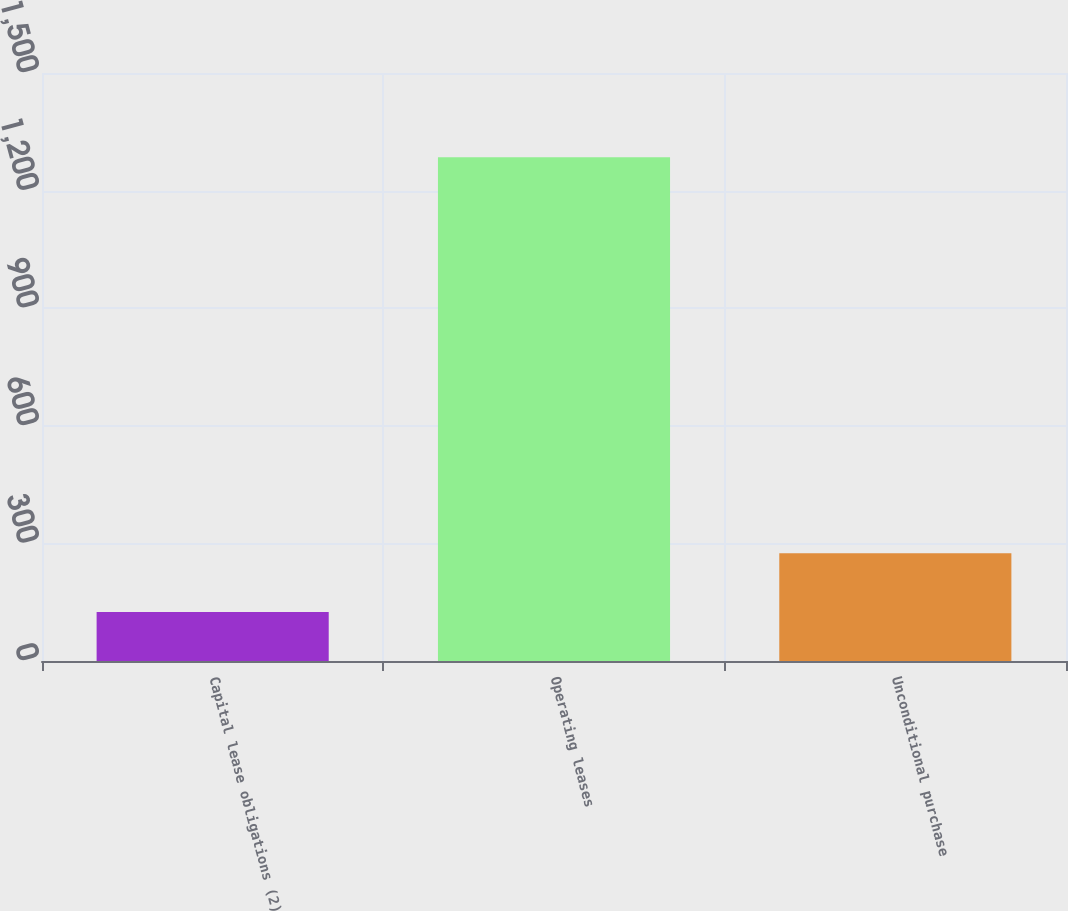Convert chart to OTSL. <chart><loc_0><loc_0><loc_500><loc_500><bar_chart><fcel>Capital lease obligations (2)<fcel>Operating leases<fcel>Unconditional purchase<nl><fcel>125<fcel>1285<fcel>275<nl></chart> 